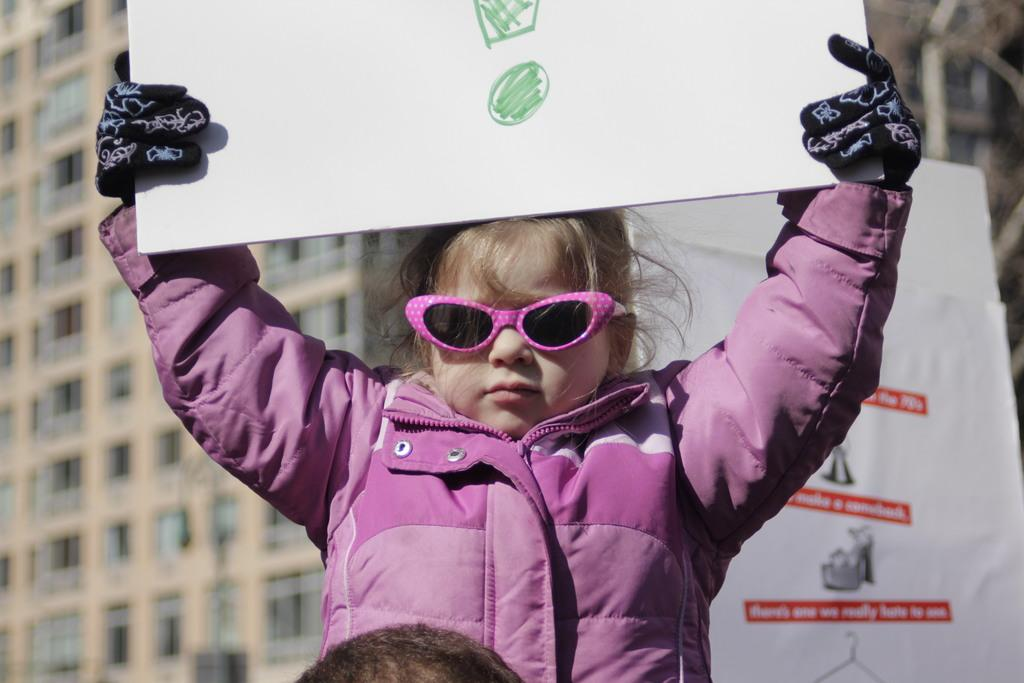What is the main subject of the image? The main subject of the image is a kid. What is the kid holding in the image? The kid is holding a poster. What can be seen in the background of the image? There is a building in the background of the image. What architectural feature is visible on the building? There are windows visible on the building. What time of day is it in the image, based on the current and morning? The provided facts do not give any information about the time of day, so it cannot be determined based on the current or morning. 